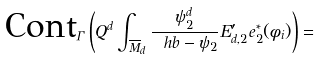<formula> <loc_0><loc_0><loc_500><loc_500>\text {Cont} _ { \Gamma } \left ( Q ^ { d } \int _ { \overline { M } _ { d } } \frac { \psi _ { 2 } ^ { d } } { \ h b - \psi _ { 2 } } E ^ { \prime } _ { d , 2 } e _ { 2 } ^ { * } ( \phi _ { i } ) \right ) =</formula> 